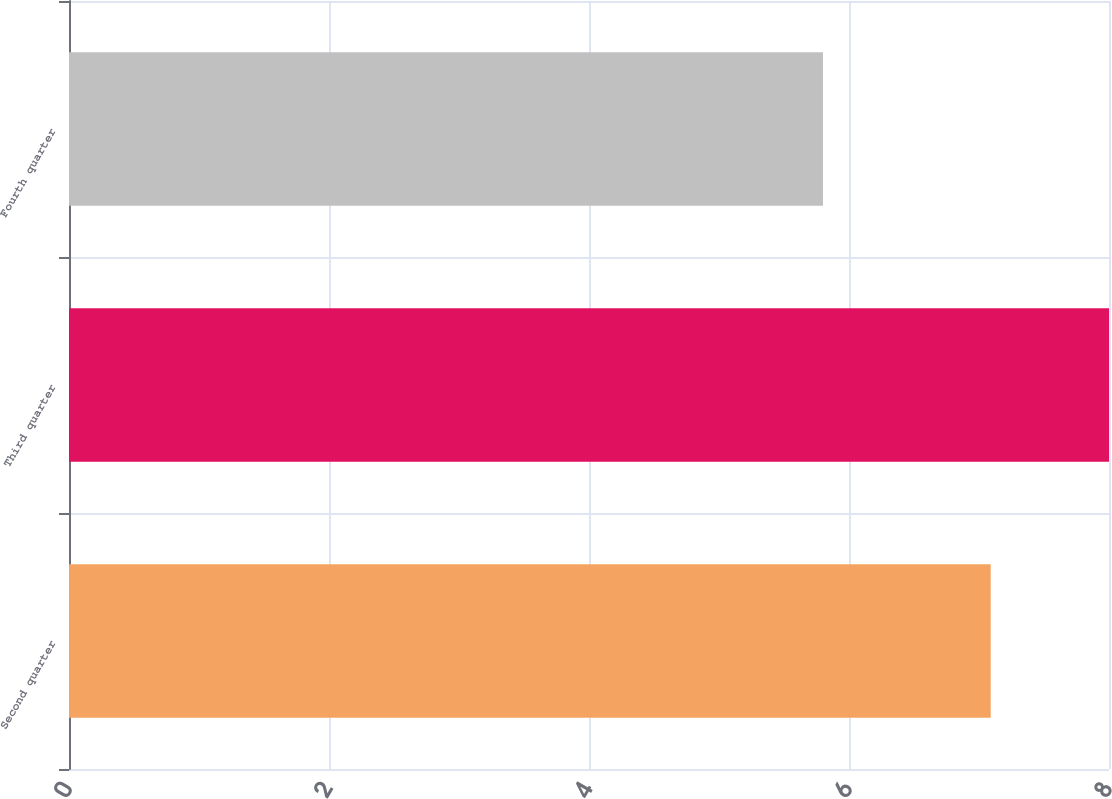Convert chart. <chart><loc_0><loc_0><loc_500><loc_500><bar_chart><fcel>Second quarter<fcel>Third quarter<fcel>Fourth quarter<nl><fcel>7.09<fcel>8<fcel>5.8<nl></chart> 